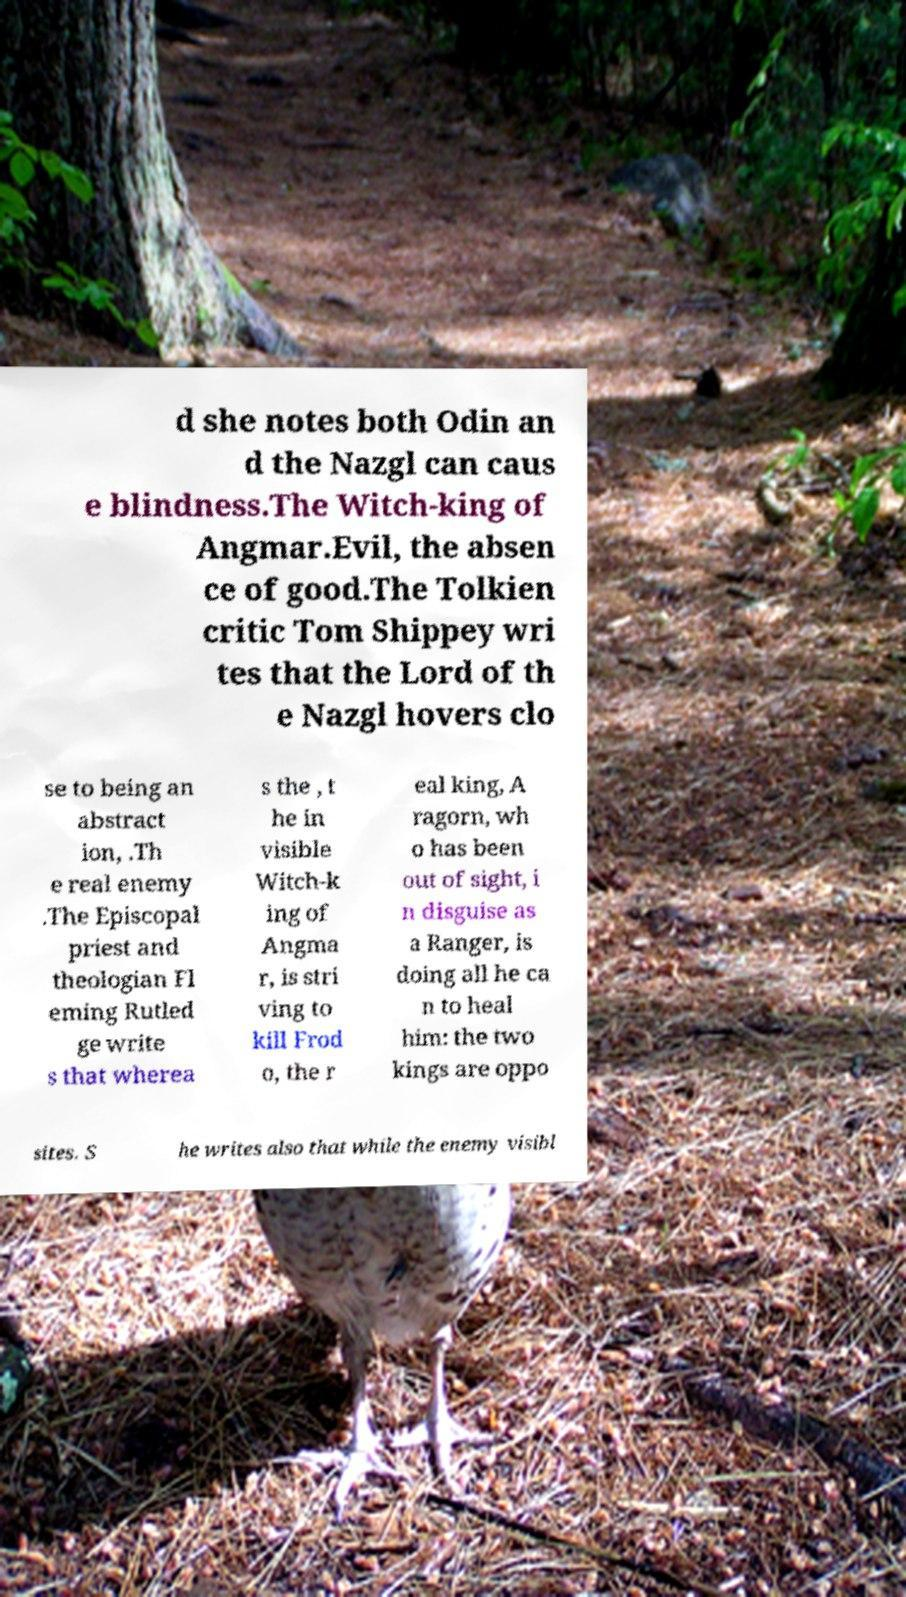Please read and relay the text visible in this image. What does it say? d she notes both Odin an d the Nazgl can caus e blindness.The Witch-king of Angmar.Evil, the absen ce of good.The Tolkien critic Tom Shippey wri tes that the Lord of th e Nazgl hovers clo se to being an abstract ion, .Th e real enemy .The Episcopal priest and theologian Fl eming Rutled ge write s that wherea s the , t he in visible Witch-k ing of Angma r, is stri ving to kill Frod o, the r eal king, A ragorn, wh o has been out of sight, i n disguise as a Ranger, is doing all he ca n to heal him: the two kings are oppo sites. S he writes also that while the enemy visibl 